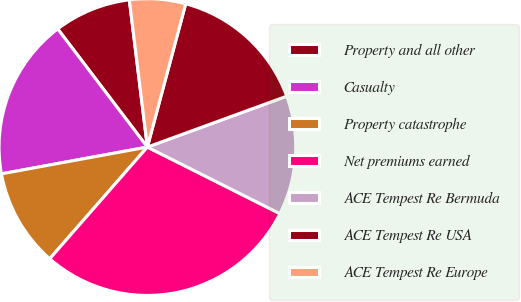Convert chart to OTSL. <chart><loc_0><loc_0><loc_500><loc_500><pie_chart><fcel>Property and all other<fcel>Casualty<fcel>Property catastrophe<fcel>Net premiums earned<fcel>ACE Tempest Re Bermuda<fcel>ACE Tempest Re USA<fcel>ACE Tempest Re Europe<nl><fcel>8.39%<fcel>17.56%<fcel>10.68%<fcel>29.03%<fcel>12.98%<fcel>15.27%<fcel>6.1%<nl></chart> 